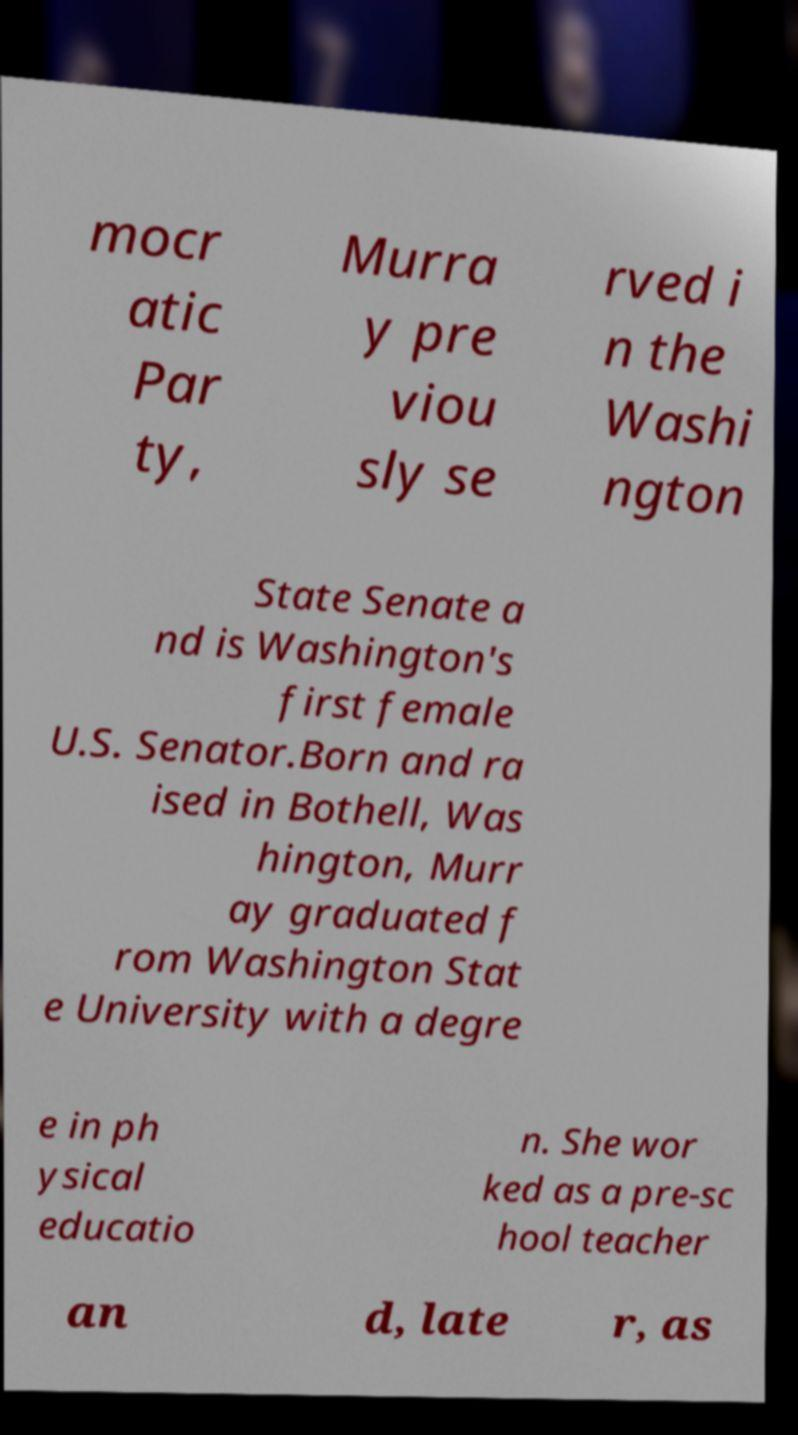What messages or text are displayed in this image? I need them in a readable, typed format. mocr atic Par ty, Murra y pre viou sly se rved i n the Washi ngton State Senate a nd is Washington's first female U.S. Senator.Born and ra ised in Bothell, Was hington, Murr ay graduated f rom Washington Stat e University with a degre e in ph ysical educatio n. She wor ked as a pre-sc hool teacher an d, late r, as 